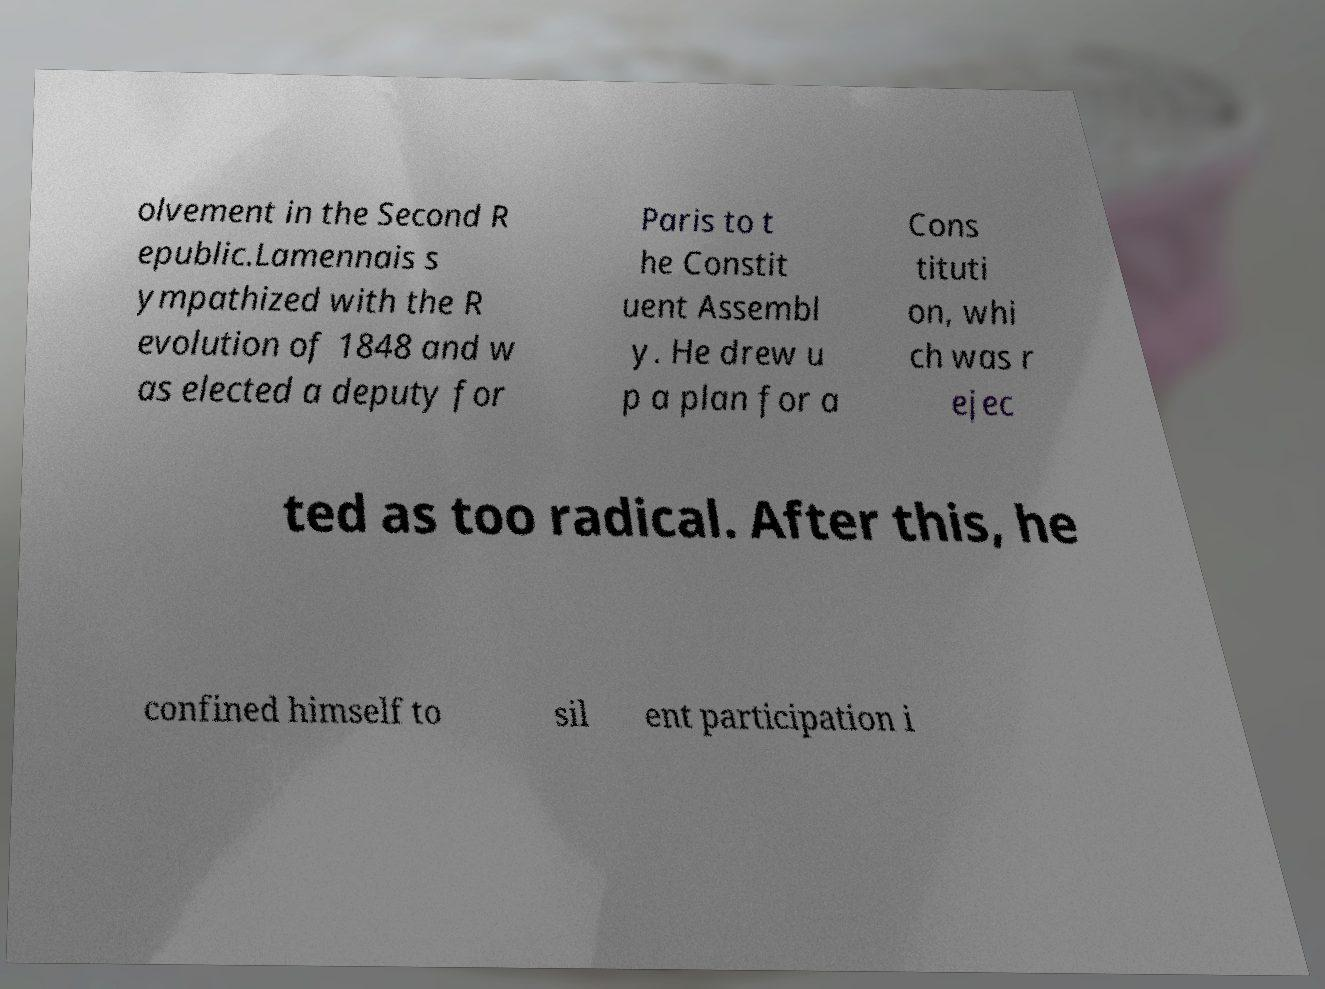Please identify and transcribe the text found in this image. olvement in the Second R epublic.Lamennais s ympathized with the R evolution of 1848 and w as elected a deputy for Paris to t he Constit uent Assembl y. He drew u p a plan for a Cons tituti on, whi ch was r ejec ted as too radical. After this, he confined himself to sil ent participation i 